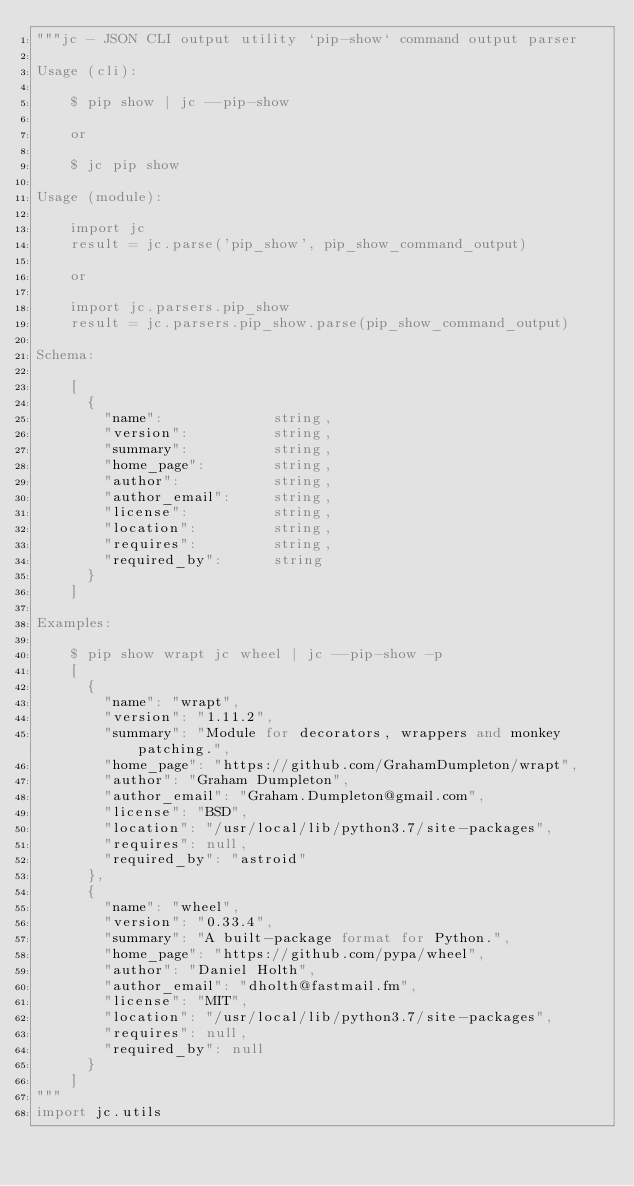<code> <loc_0><loc_0><loc_500><loc_500><_Python_>"""jc - JSON CLI output utility `pip-show` command output parser

Usage (cli):

    $ pip show | jc --pip-show

    or

    $ jc pip show

Usage (module):

    import jc
    result = jc.parse('pip_show', pip_show_command_output)

    or

    import jc.parsers.pip_show
    result = jc.parsers.pip_show.parse(pip_show_command_output)

Schema:

    [
      {
        "name":             string,
        "version":          string,
        "summary":          string,
        "home_page":        string,
        "author":           string,
        "author_email":     string,
        "license":          string,
        "location":         string,
        "requires":         string,
        "required_by":      string
      }
    ]

Examples:

    $ pip show wrapt jc wheel | jc --pip-show -p
    [
      {
        "name": "wrapt",
        "version": "1.11.2",
        "summary": "Module for decorators, wrappers and monkey patching.",
        "home_page": "https://github.com/GrahamDumpleton/wrapt",
        "author": "Graham Dumpleton",
        "author_email": "Graham.Dumpleton@gmail.com",
        "license": "BSD",
        "location": "/usr/local/lib/python3.7/site-packages",
        "requires": null,
        "required_by": "astroid"
      },
      {
        "name": "wheel",
        "version": "0.33.4",
        "summary": "A built-package format for Python.",
        "home_page": "https://github.com/pypa/wheel",
        "author": "Daniel Holth",
        "author_email": "dholth@fastmail.fm",
        "license": "MIT",
        "location": "/usr/local/lib/python3.7/site-packages",
        "requires": null,
        "required_by": null
      }
    ]
"""
import jc.utils

</code> 